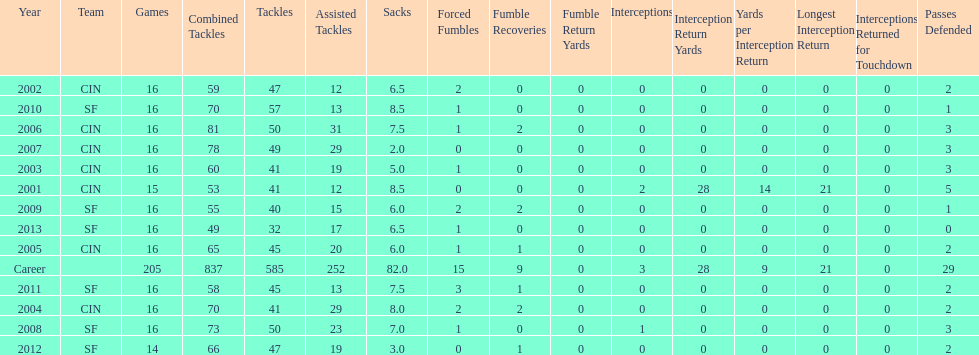How many sacks did this player have in his first five seasons? 34. 